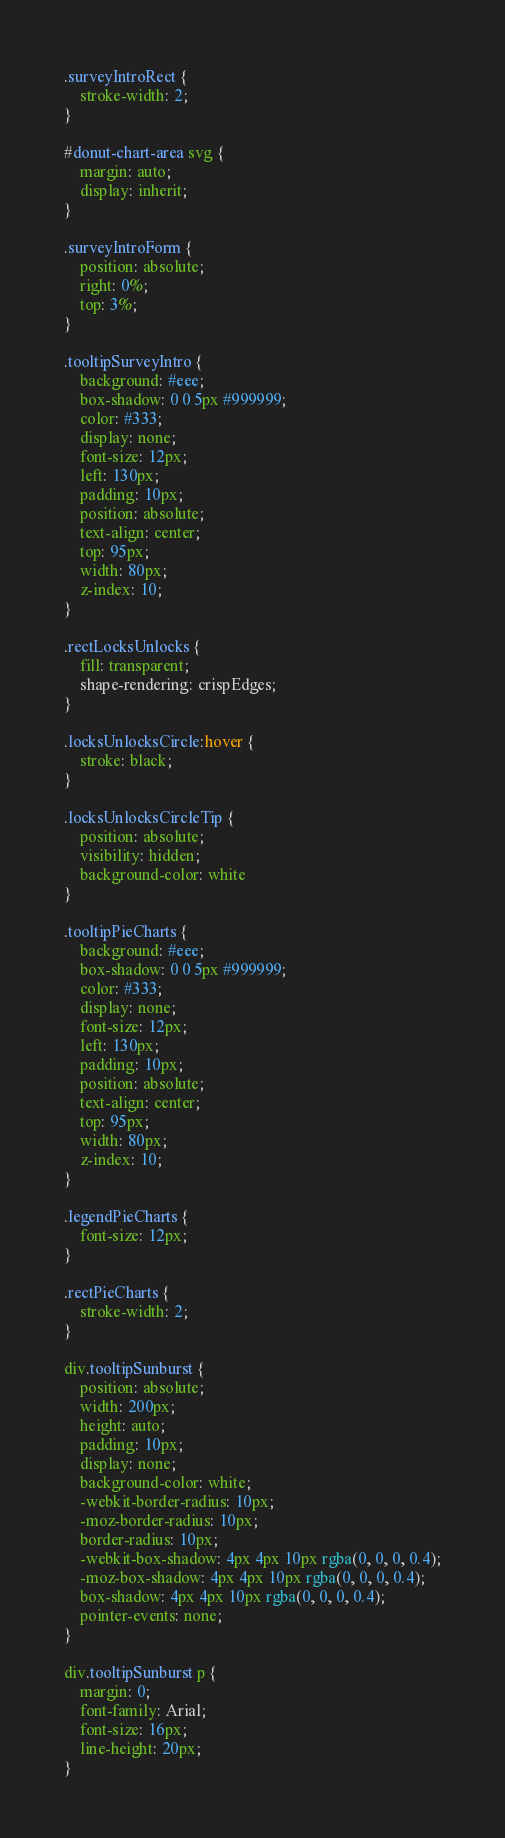<code> <loc_0><loc_0><loc_500><loc_500><_CSS_>.surveyIntroRect {
    stroke-width: 2;
}

#donut-chart-area svg {
    margin: auto;
    display: inherit;
}

.surveyIntroForm {
    position: absolute;
    right: 0%;
    top: 3%;
}

.tooltipSurveyIntro {
    background: #eee;
    box-shadow: 0 0 5px #999999;
    color: #333;
    display: none;
    font-size: 12px;
    left: 130px;
    padding: 10px;
    position: absolute;
    text-align: center;
    top: 95px;
    width: 80px;
    z-index: 10;
}

.rectLocksUnlocks {
    fill: transparent;
    shape-rendering: crispEdges;
}

.locksUnlocksCircle:hover {
    stroke: black;
}

.locksUnlocksCircleTip {
    position: absolute;
    visibility: hidden;
    background-color: white
}

.tooltipPieCharts {
    background: #eee;
    box-shadow: 0 0 5px #999999;
    color: #333;
    display: none;
    font-size: 12px;
    left: 130px;
    padding: 10px;
    position: absolute;
    text-align: center;
    top: 95px;
    width: 80px;
    z-index: 10;
}

.legendPieCharts {
    font-size: 12px;
}

.rectPieCharts {
    stroke-width: 2;
}

div.tooltipSunburst {
    position: absolute;
    width: 200px;
    height: auto;
    padding: 10px;
    display: none;
    background-color: white;
    -webkit-border-radius: 10px;
    -moz-border-radius: 10px;
    border-radius: 10px;
    -webkit-box-shadow: 4px 4px 10px rgba(0, 0, 0, 0.4);
    -moz-box-shadow: 4px 4px 10px rgba(0, 0, 0, 0.4);
    box-shadow: 4px 4px 10px rgba(0, 0, 0, 0.4);
    pointer-events: none;
}

div.tooltipSunburst p {
    margin: 0;
    font-family: Arial;
    font-size: 16px;
    line-height: 20px;
}</code> 